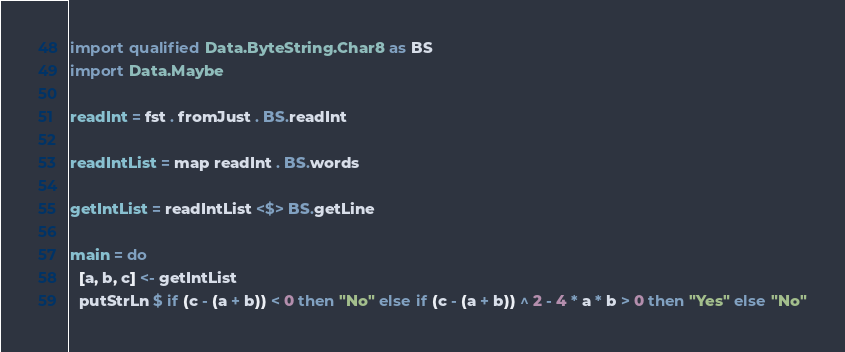<code> <loc_0><loc_0><loc_500><loc_500><_Haskell_>import qualified Data.ByteString.Char8 as BS
import Data.Maybe

readInt = fst . fromJust . BS.readInt

readIntList = map readInt . BS.words

getIntList = readIntList <$> BS.getLine

main = do
  [a, b, c] <- getIntList
  putStrLn $ if (c - (a + b)) < 0 then "No" else if (c - (a + b)) ^ 2 - 4 * a * b > 0 then "Yes" else "No"
</code> 